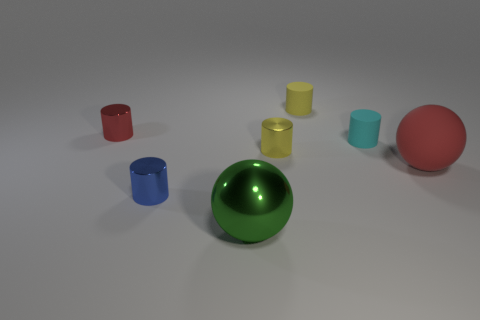What number of things are the same color as the big rubber sphere?
Ensure brevity in your answer.  1. There is a small cylinder that is the same color as the large matte sphere; what is its material?
Offer a very short reply. Metal. Is there any other thing that has the same material as the cyan object?
Ensure brevity in your answer.  Yes. There is a small red cylinder that is left of the tiny matte cylinder in front of the red thing that is left of the green ball; what is it made of?
Provide a short and direct response. Metal. What material is the object that is both behind the big red matte object and to the right of the yellow matte cylinder?
Provide a short and direct response. Rubber. What number of big gray rubber objects are the same shape as the tiny yellow matte thing?
Ensure brevity in your answer.  0. There is a metallic thing that is behind the tiny matte object in front of the yellow matte cylinder; what size is it?
Provide a succinct answer. Small. There is a large object behind the big shiny object; is its color the same as the small metal cylinder that is to the right of the small blue cylinder?
Provide a succinct answer. No. What number of large red spheres are in front of the cylinder that is on the left side of the blue object that is left of the yellow metallic cylinder?
Offer a terse response. 1. How many objects are both right of the red shiny cylinder and in front of the tiny yellow matte cylinder?
Your response must be concise. 5. 